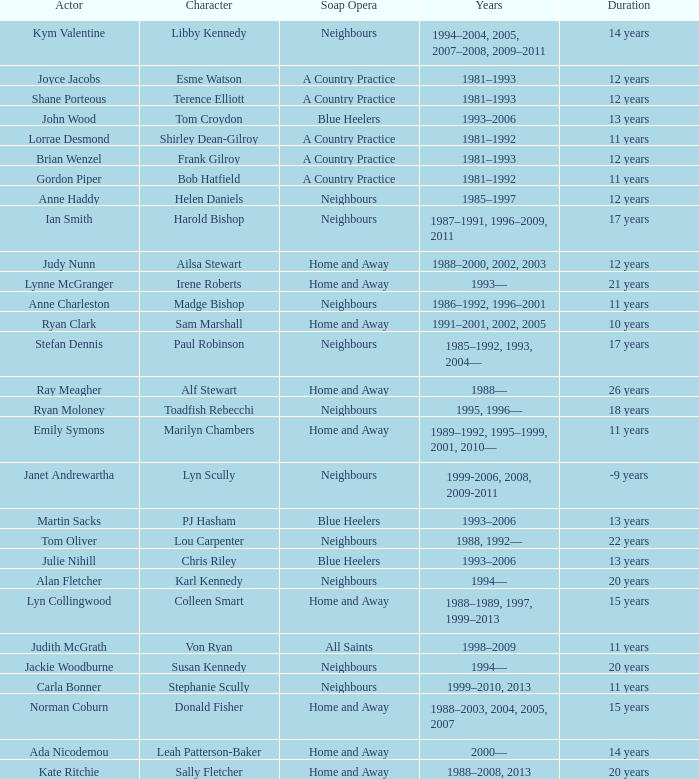Which actor played Harold Bishop for 17 years? Ian Smith. 